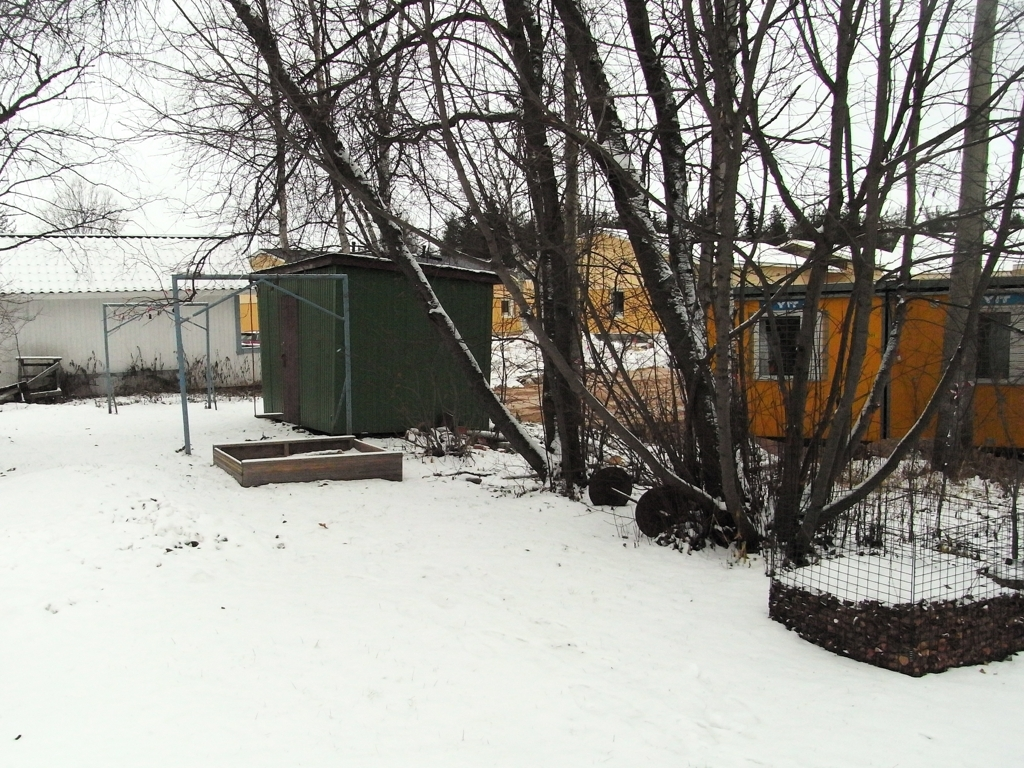Are there any evident focus problems in the image?
 No 